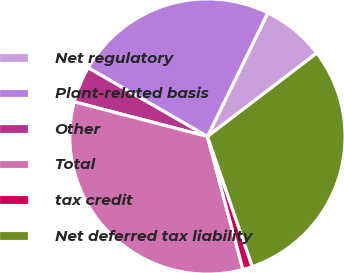Convert chart to OTSL. <chart><loc_0><loc_0><loc_500><loc_500><pie_chart><fcel>Net regulatory<fcel>Plant-related basis<fcel>Other<fcel>Total<fcel>tax credit<fcel>Net deferred tax liability<nl><fcel>7.4%<fcel>23.91%<fcel>4.26%<fcel>33.21%<fcel>1.13%<fcel>30.08%<nl></chart> 